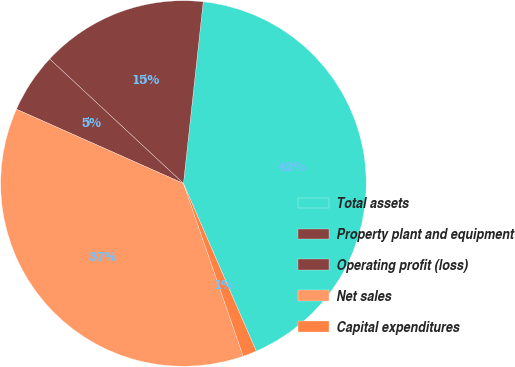<chart> <loc_0><loc_0><loc_500><loc_500><pie_chart><fcel>Total assets<fcel>Property plant and equipment<fcel>Operating profit (loss)<fcel>Net sales<fcel>Capital expenditures<nl><fcel>41.76%<fcel>14.8%<fcel>5.27%<fcel>36.96%<fcel>1.22%<nl></chart> 